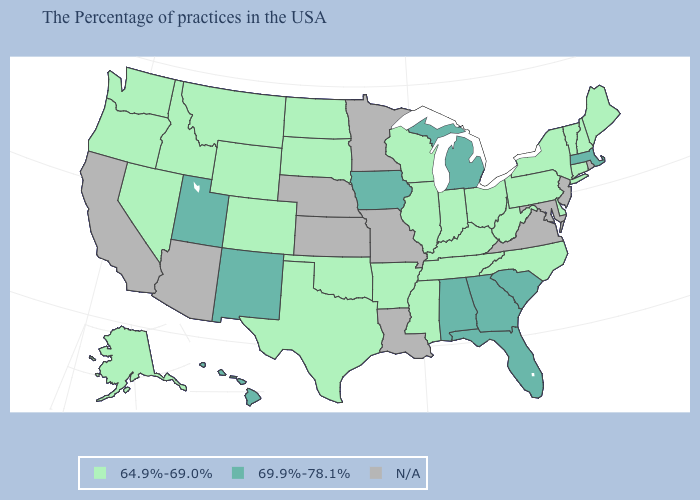What is the value of Arkansas?
Quick response, please. 64.9%-69.0%. What is the highest value in the USA?
Concise answer only. 69.9%-78.1%. Which states have the lowest value in the USA?
Give a very brief answer. Maine, New Hampshire, Vermont, Connecticut, New York, Delaware, Pennsylvania, North Carolina, West Virginia, Ohio, Kentucky, Indiana, Tennessee, Wisconsin, Illinois, Mississippi, Arkansas, Oklahoma, Texas, South Dakota, North Dakota, Wyoming, Colorado, Montana, Idaho, Nevada, Washington, Oregon, Alaska. Does Iowa have the highest value in the MidWest?
Keep it brief. Yes. Does Georgia have the lowest value in the USA?
Quick response, please. No. How many symbols are there in the legend?
Concise answer only. 3. What is the lowest value in states that border Virginia?
Write a very short answer. 64.9%-69.0%. Does the first symbol in the legend represent the smallest category?
Give a very brief answer. Yes. Which states have the lowest value in the USA?
Concise answer only. Maine, New Hampshire, Vermont, Connecticut, New York, Delaware, Pennsylvania, North Carolina, West Virginia, Ohio, Kentucky, Indiana, Tennessee, Wisconsin, Illinois, Mississippi, Arkansas, Oklahoma, Texas, South Dakota, North Dakota, Wyoming, Colorado, Montana, Idaho, Nevada, Washington, Oregon, Alaska. What is the value of Illinois?
Write a very short answer. 64.9%-69.0%. Name the states that have a value in the range 64.9%-69.0%?
Short answer required. Maine, New Hampshire, Vermont, Connecticut, New York, Delaware, Pennsylvania, North Carolina, West Virginia, Ohio, Kentucky, Indiana, Tennessee, Wisconsin, Illinois, Mississippi, Arkansas, Oklahoma, Texas, South Dakota, North Dakota, Wyoming, Colorado, Montana, Idaho, Nevada, Washington, Oregon, Alaska. Does the first symbol in the legend represent the smallest category?
Keep it brief. Yes. Name the states that have a value in the range 64.9%-69.0%?
Short answer required. Maine, New Hampshire, Vermont, Connecticut, New York, Delaware, Pennsylvania, North Carolina, West Virginia, Ohio, Kentucky, Indiana, Tennessee, Wisconsin, Illinois, Mississippi, Arkansas, Oklahoma, Texas, South Dakota, North Dakota, Wyoming, Colorado, Montana, Idaho, Nevada, Washington, Oregon, Alaska. 